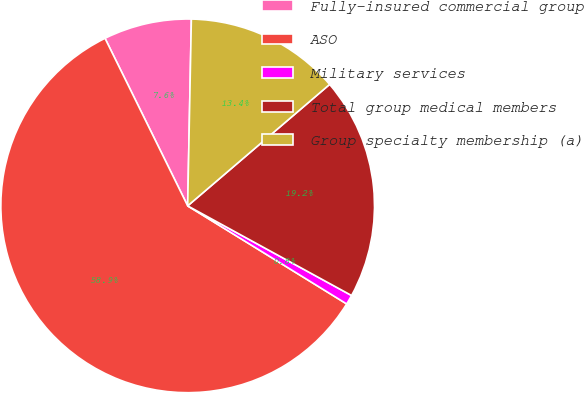Convert chart. <chart><loc_0><loc_0><loc_500><loc_500><pie_chart><fcel>Fully-insured commercial group<fcel>ASO<fcel>Military services<fcel>Total group medical members<fcel>Group specialty membership (a)<nl><fcel>7.61%<fcel>58.91%<fcel>0.83%<fcel>19.23%<fcel>13.42%<nl></chart> 